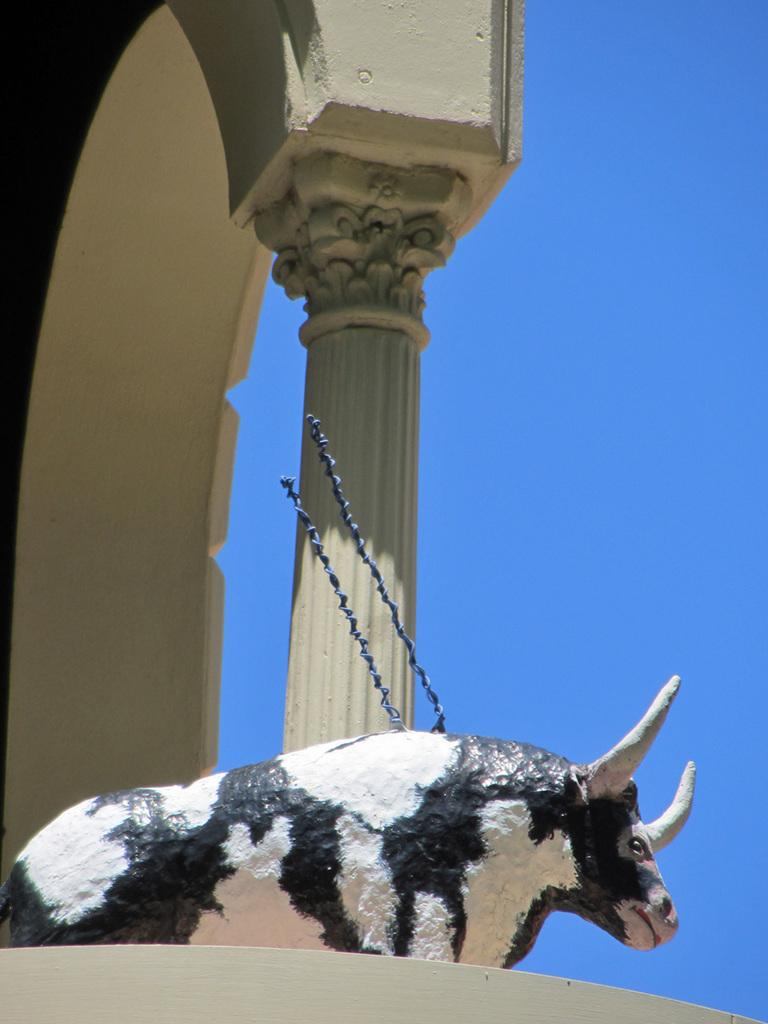What is the main subject in the center of the image? There is a statue of a bull in the center of the image. What can be seen in the background of the image? There is a pillar and a building in the background of the image. What is visible at the top of the image? The sky is visible at the top of the image. How many cakes are stacked on top of the rock in the image? There is no rock or cakes present in the image. 